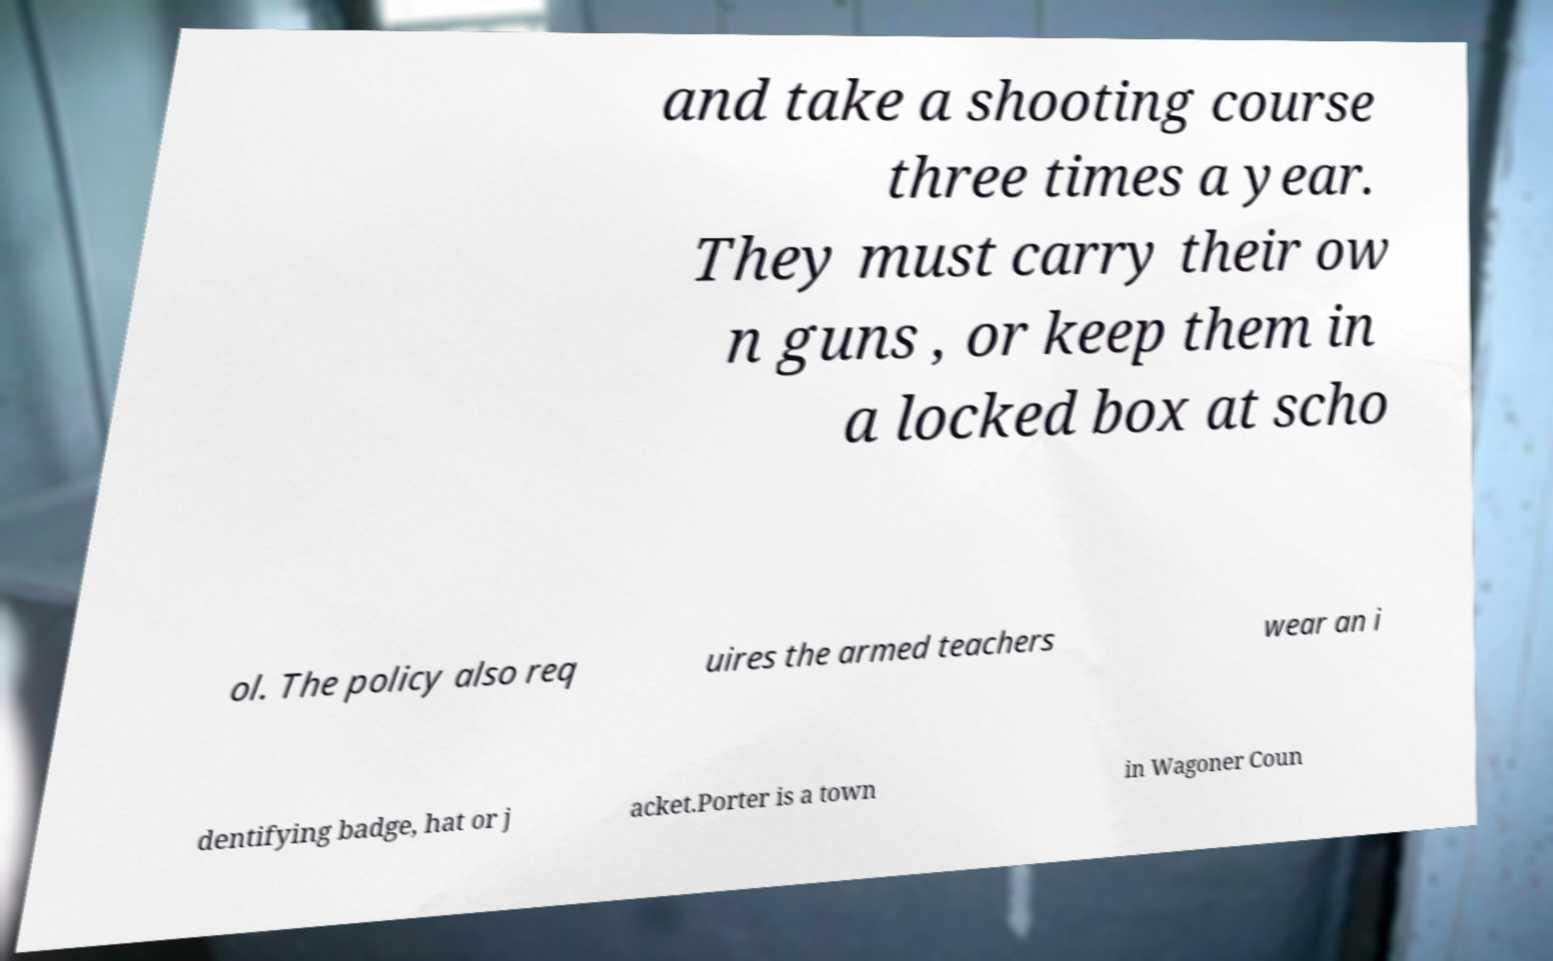Can you accurately transcribe the text from the provided image for me? and take a shooting course three times a year. They must carry their ow n guns , or keep them in a locked box at scho ol. The policy also req uires the armed teachers wear an i dentifying badge, hat or j acket.Porter is a town in Wagoner Coun 